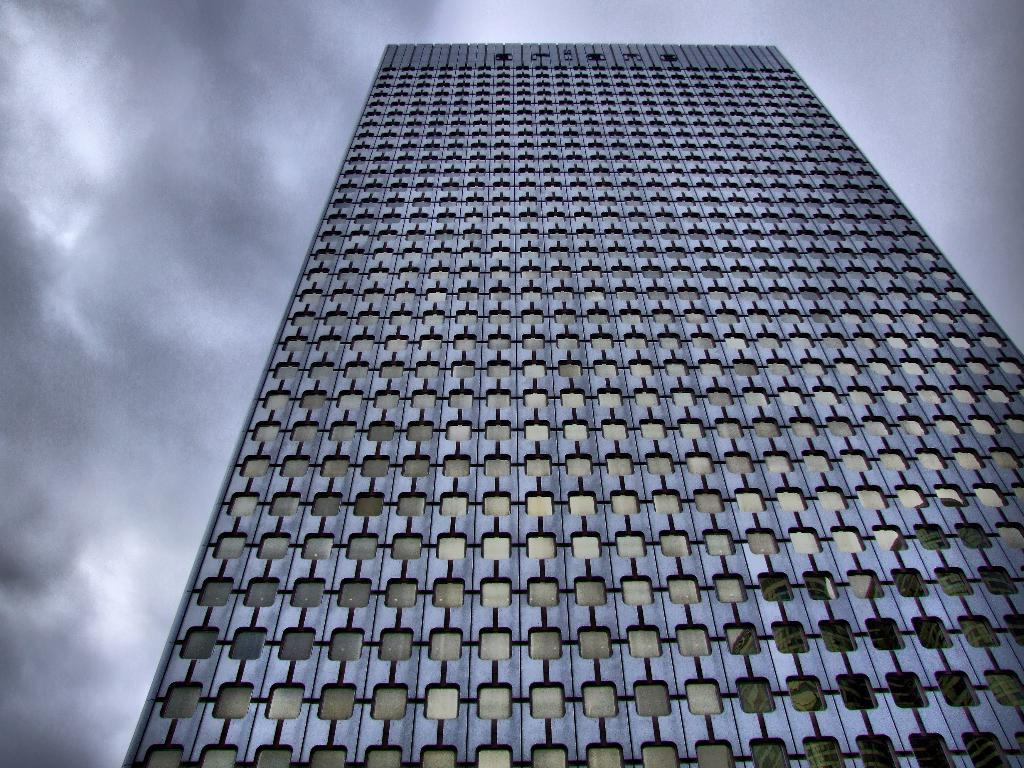What type of structure is present in the image? There is a building in the image. What can be seen in the sky in the image? There are clouds visible in the image. What type of utensil is being used to stir the clouds in the image? There is no utensil present in the image, and the clouds are not being stirred. How many chairs are visible in the image? There are no chairs present in the image. 